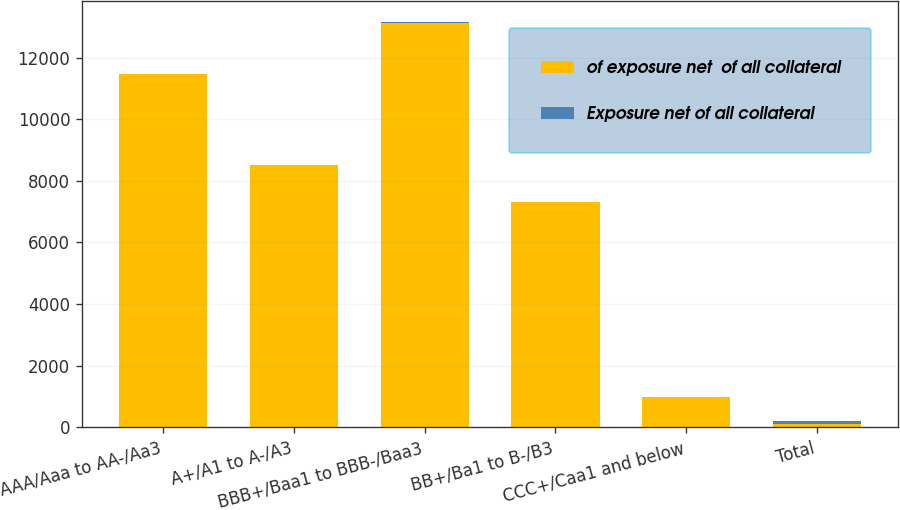<chart> <loc_0><loc_0><loc_500><loc_500><stacked_bar_chart><ecel><fcel>AAA/Aaa to AA-/Aa3<fcel>A+/A1 to A-/A3<fcel>BBB+/Baa1 to BBB-/Baa3<fcel>BB+/Ba1 to B-/B3<fcel>CCC+/Caa1 and below<fcel>Total<nl><fcel>of exposure net  of all collateral<fcel>11449<fcel>8505<fcel>13127<fcel>7308<fcel>984<fcel>100<nl><fcel>Exposure net of all collateral<fcel>28<fcel>20<fcel>32<fcel>18<fcel>2<fcel>100<nl></chart> 